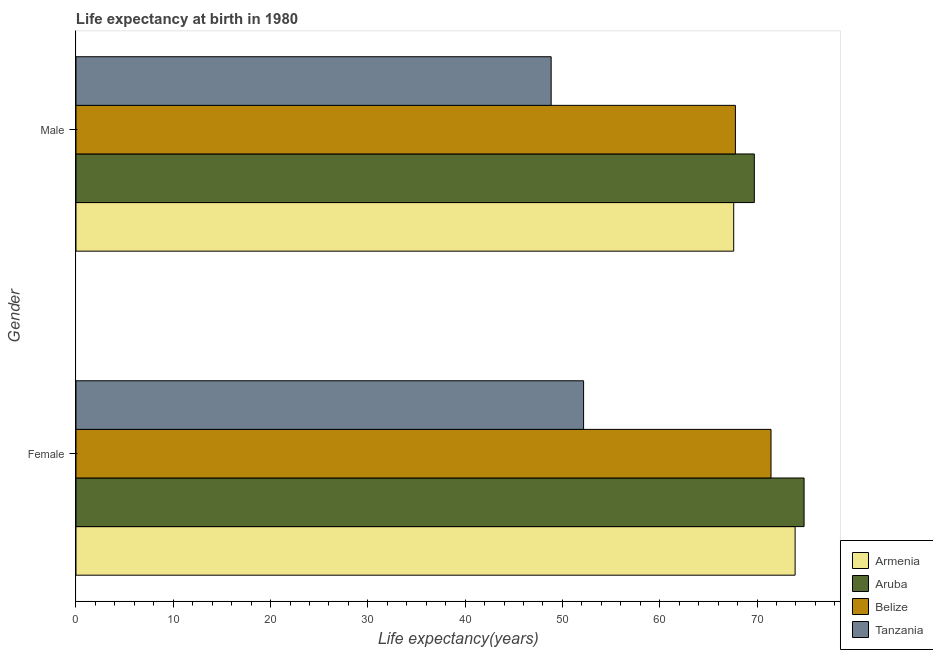How many different coloured bars are there?
Offer a very short reply. 4. Are the number of bars on each tick of the Y-axis equal?
Ensure brevity in your answer.  Yes. How many bars are there on the 2nd tick from the top?
Your answer should be compact. 4. What is the label of the 1st group of bars from the top?
Your answer should be very brief. Male. What is the life expectancy(male) in Tanzania?
Offer a terse response. 48.84. Across all countries, what is the maximum life expectancy(male)?
Offer a terse response. 69.73. Across all countries, what is the minimum life expectancy(male)?
Your answer should be very brief. 48.84. In which country was the life expectancy(male) maximum?
Offer a terse response. Aruba. In which country was the life expectancy(male) minimum?
Your answer should be very brief. Tanzania. What is the total life expectancy(female) in the graph?
Offer a terse response. 272.37. What is the difference between the life expectancy(male) in Tanzania and that in Aruba?
Your answer should be very brief. -20.88. What is the difference between the life expectancy(female) in Belize and the life expectancy(male) in Aruba?
Offer a very short reply. 1.72. What is the average life expectancy(female) per country?
Keep it short and to the point. 68.09. What is the difference between the life expectancy(male) and life expectancy(female) in Tanzania?
Your answer should be very brief. -3.33. What is the ratio of the life expectancy(male) in Tanzania to that in Armenia?
Make the answer very short. 0.72. What does the 4th bar from the top in Male represents?
Your answer should be very brief. Armenia. What does the 1st bar from the bottom in Male represents?
Give a very brief answer. Armenia. Are all the bars in the graph horizontal?
Keep it short and to the point. Yes. How many countries are there in the graph?
Your response must be concise. 4. What is the difference between two consecutive major ticks on the X-axis?
Provide a succinct answer. 10. Are the values on the major ticks of X-axis written in scientific E-notation?
Provide a short and direct response. No. Where does the legend appear in the graph?
Ensure brevity in your answer.  Bottom right. How many legend labels are there?
Your answer should be very brief. 4. What is the title of the graph?
Keep it short and to the point. Life expectancy at birth in 1980. What is the label or title of the X-axis?
Provide a succinct answer. Life expectancy(years). What is the Life expectancy(years) in Armenia in Female?
Offer a very short reply. 73.92. What is the Life expectancy(years) of Aruba in Female?
Make the answer very short. 74.84. What is the Life expectancy(years) of Belize in Female?
Make the answer very short. 71.44. What is the Life expectancy(years) in Tanzania in Female?
Give a very brief answer. 52.18. What is the Life expectancy(years) in Armenia in Male?
Offer a terse response. 67.61. What is the Life expectancy(years) of Aruba in Male?
Your answer should be compact. 69.73. What is the Life expectancy(years) in Belize in Male?
Keep it short and to the point. 67.78. What is the Life expectancy(years) of Tanzania in Male?
Your response must be concise. 48.84. Across all Gender, what is the maximum Life expectancy(years) of Armenia?
Ensure brevity in your answer.  73.92. Across all Gender, what is the maximum Life expectancy(years) in Aruba?
Offer a very short reply. 74.84. Across all Gender, what is the maximum Life expectancy(years) of Belize?
Your answer should be compact. 71.44. Across all Gender, what is the maximum Life expectancy(years) of Tanzania?
Offer a terse response. 52.18. Across all Gender, what is the minimum Life expectancy(years) of Armenia?
Keep it short and to the point. 67.61. Across all Gender, what is the minimum Life expectancy(years) of Aruba?
Provide a succinct answer. 69.73. Across all Gender, what is the minimum Life expectancy(years) of Belize?
Give a very brief answer. 67.78. Across all Gender, what is the minimum Life expectancy(years) in Tanzania?
Keep it short and to the point. 48.84. What is the total Life expectancy(years) in Armenia in the graph?
Provide a succinct answer. 141.52. What is the total Life expectancy(years) of Aruba in the graph?
Your answer should be compact. 144.56. What is the total Life expectancy(years) in Belize in the graph?
Your response must be concise. 139.22. What is the total Life expectancy(years) of Tanzania in the graph?
Provide a succinct answer. 101.02. What is the difference between the Life expectancy(years) in Armenia in Female and that in Male?
Your response must be concise. 6.31. What is the difference between the Life expectancy(years) of Aruba in Female and that in Male?
Make the answer very short. 5.11. What is the difference between the Life expectancy(years) of Belize in Female and that in Male?
Offer a terse response. 3.66. What is the difference between the Life expectancy(years) of Tanzania in Female and that in Male?
Your answer should be very brief. 3.33. What is the difference between the Life expectancy(years) of Armenia in Female and the Life expectancy(years) of Aruba in Male?
Your answer should be very brief. 4.19. What is the difference between the Life expectancy(years) in Armenia in Female and the Life expectancy(years) in Belize in Male?
Your answer should be compact. 6.14. What is the difference between the Life expectancy(years) in Armenia in Female and the Life expectancy(years) in Tanzania in Male?
Keep it short and to the point. 25.07. What is the difference between the Life expectancy(years) in Aruba in Female and the Life expectancy(years) in Belize in Male?
Offer a terse response. 7.06. What is the difference between the Life expectancy(years) of Aruba in Female and the Life expectancy(years) of Tanzania in Male?
Offer a terse response. 26. What is the difference between the Life expectancy(years) in Belize in Female and the Life expectancy(years) in Tanzania in Male?
Provide a succinct answer. 22.6. What is the average Life expectancy(years) in Armenia per Gender?
Your answer should be compact. 70.76. What is the average Life expectancy(years) of Aruba per Gender?
Your answer should be compact. 72.28. What is the average Life expectancy(years) of Belize per Gender?
Keep it short and to the point. 69.61. What is the average Life expectancy(years) in Tanzania per Gender?
Provide a short and direct response. 50.51. What is the difference between the Life expectancy(years) in Armenia and Life expectancy(years) in Aruba in Female?
Give a very brief answer. -0.92. What is the difference between the Life expectancy(years) of Armenia and Life expectancy(years) of Belize in Female?
Give a very brief answer. 2.48. What is the difference between the Life expectancy(years) of Armenia and Life expectancy(years) of Tanzania in Female?
Give a very brief answer. 21.74. What is the difference between the Life expectancy(years) of Aruba and Life expectancy(years) of Belize in Female?
Provide a succinct answer. 3.4. What is the difference between the Life expectancy(years) of Aruba and Life expectancy(years) of Tanzania in Female?
Your response must be concise. 22.66. What is the difference between the Life expectancy(years) of Belize and Life expectancy(years) of Tanzania in Female?
Your answer should be very brief. 19.27. What is the difference between the Life expectancy(years) in Armenia and Life expectancy(years) in Aruba in Male?
Offer a terse response. -2.12. What is the difference between the Life expectancy(years) in Armenia and Life expectancy(years) in Belize in Male?
Provide a short and direct response. -0.17. What is the difference between the Life expectancy(years) of Armenia and Life expectancy(years) of Tanzania in Male?
Provide a short and direct response. 18.76. What is the difference between the Life expectancy(years) of Aruba and Life expectancy(years) of Belize in Male?
Offer a very short reply. 1.95. What is the difference between the Life expectancy(years) in Aruba and Life expectancy(years) in Tanzania in Male?
Provide a short and direct response. 20.88. What is the difference between the Life expectancy(years) in Belize and Life expectancy(years) in Tanzania in Male?
Provide a short and direct response. 18.94. What is the ratio of the Life expectancy(years) in Armenia in Female to that in Male?
Your answer should be very brief. 1.09. What is the ratio of the Life expectancy(years) of Aruba in Female to that in Male?
Your answer should be very brief. 1.07. What is the ratio of the Life expectancy(years) in Belize in Female to that in Male?
Provide a succinct answer. 1.05. What is the ratio of the Life expectancy(years) of Tanzania in Female to that in Male?
Provide a succinct answer. 1.07. What is the difference between the highest and the second highest Life expectancy(years) in Armenia?
Give a very brief answer. 6.31. What is the difference between the highest and the second highest Life expectancy(years) in Aruba?
Offer a terse response. 5.11. What is the difference between the highest and the second highest Life expectancy(years) in Belize?
Your answer should be compact. 3.66. What is the difference between the highest and the second highest Life expectancy(years) in Tanzania?
Offer a terse response. 3.33. What is the difference between the highest and the lowest Life expectancy(years) of Armenia?
Make the answer very short. 6.31. What is the difference between the highest and the lowest Life expectancy(years) of Aruba?
Offer a very short reply. 5.11. What is the difference between the highest and the lowest Life expectancy(years) of Belize?
Offer a very short reply. 3.66. What is the difference between the highest and the lowest Life expectancy(years) of Tanzania?
Provide a short and direct response. 3.33. 